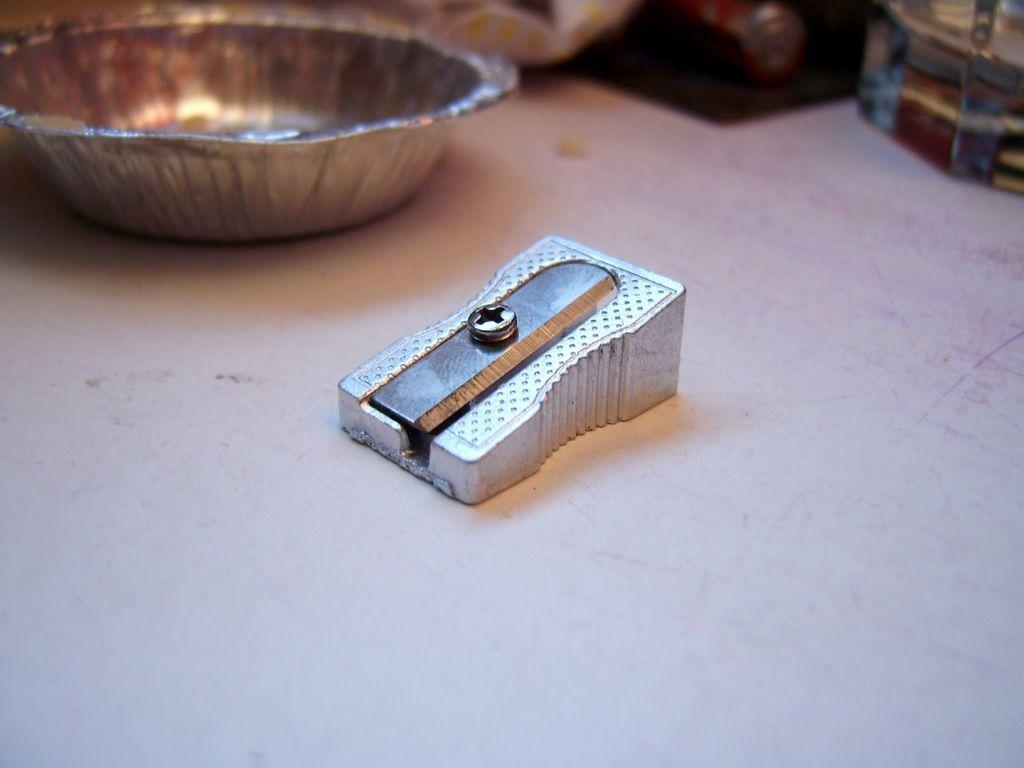Describe this image in one or two sentences. In this picture we can see a pencil sharpener in the middle, in the background we can see a cup. 